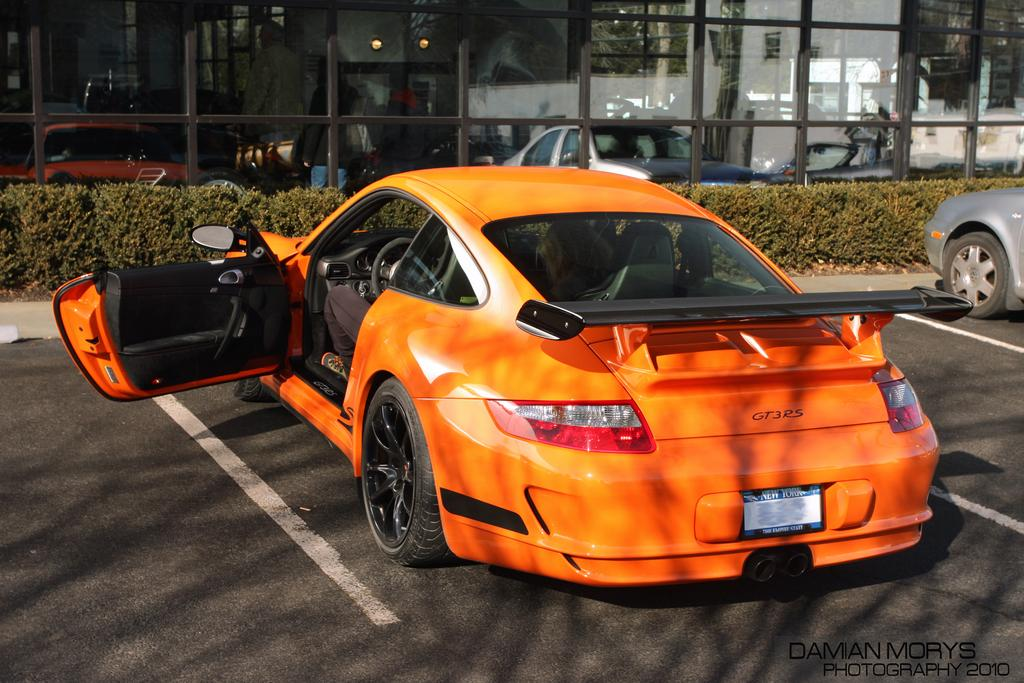What color is the car in the image? The car in the image is orange. Where is the car located in the image? The car is parked in a parking area. What can be seen behind the car? There are plants visible behind the car. What is located behind the plants? There is a big glass shop behind the plants. Can you hear any noise coming from the car's engine in the image? There is no information about the car's engine or any noise in the image. 